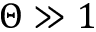Convert formula to latex. <formula><loc_0><loc_0><loc_500><loc_500>\Theta \gg 1</formula> 